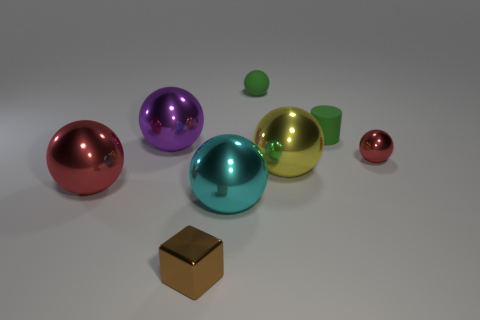The yellow ball that is the same material as the small brown cube is what size?
Ensure brevity in your answer.  Large. Is there any other thing that has the same color as the tiny metal ball?
Offer a terse response. Yes. Is the big red thing made of the same material as the small green thing that is on the left side of the yellow object?
Keep it short and to the point. No. There is a large red thing that is the same shape as the large yellow metallic object; what is it made of?
Ensure brevity in your answer.  Metal. Are the red object in front of the yellow sphere and the tiny ball that is on the left side of the small red shiny ball made of the same material?
Ensure brevity in your answer.  No. The tiny object that is in front of the sphere that is in front of the red metallic object to the left of the green cylinder is what color?
Offer a terse response. Brown. How many other things are the same shape as the big purple metal thing?
Ensure brevity in your answer.  5. Does the tiny matte cylinder have the same color as the small rubber sphere?
Offer a very short reply. Yes. What number of objects are small red metallic cylinders or red metallic objects right of the matte ball?
Your answer should be very brief. 1. Is there a brown object that has the same size as the purple metallic thing?
Give a very brief answer. No. 